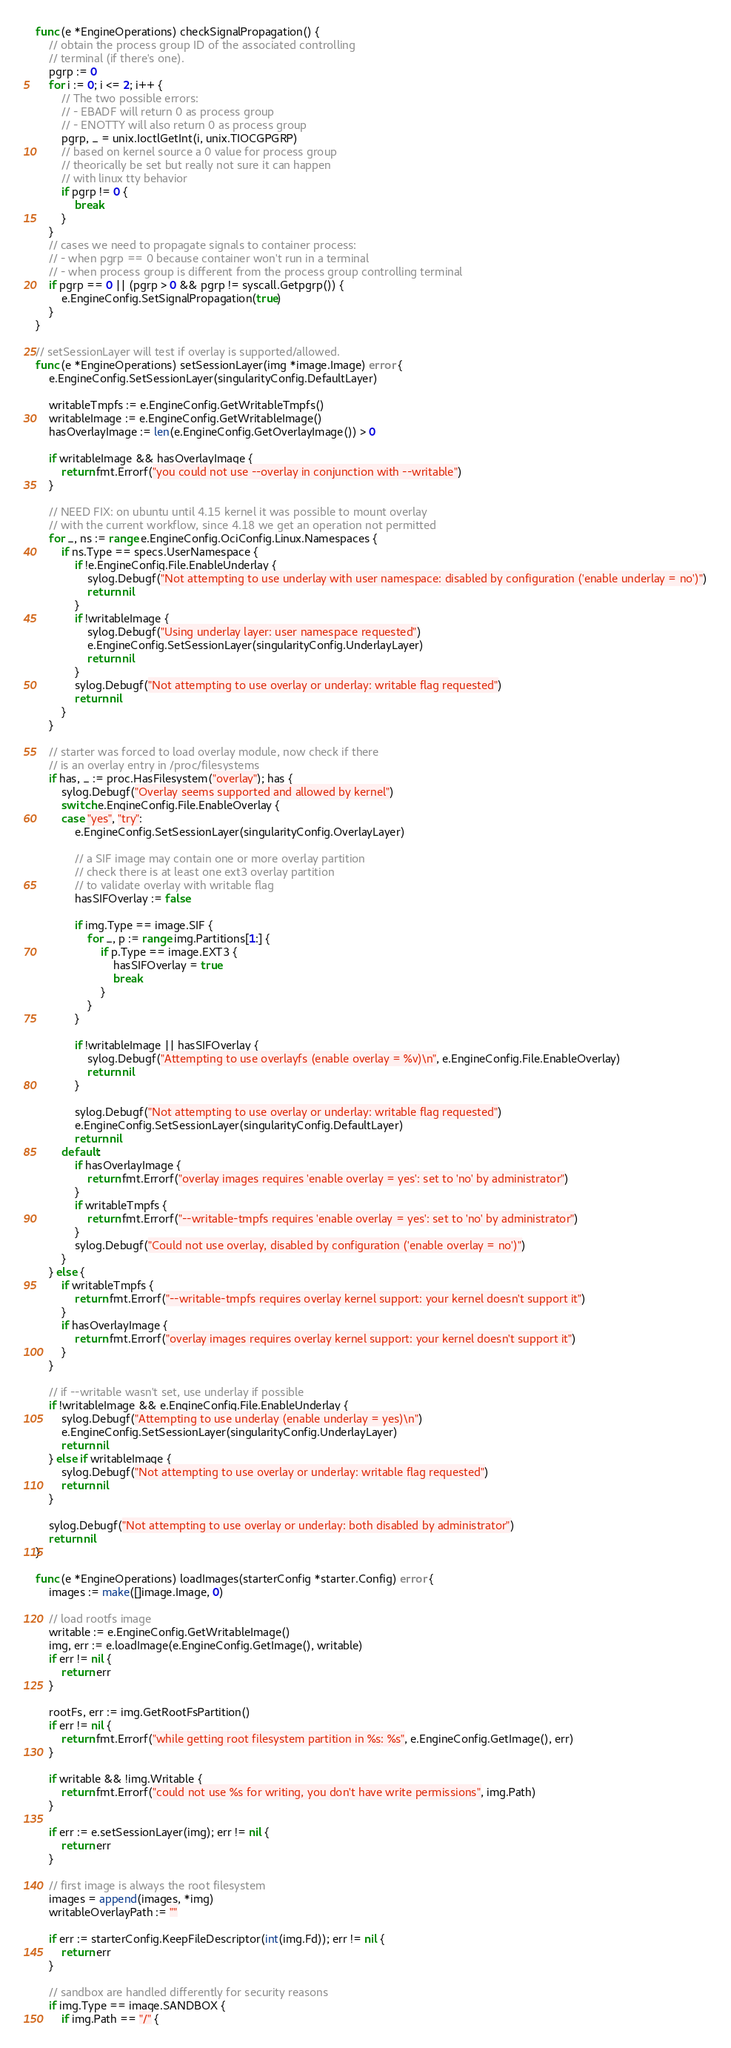Convert code to text. <code><loc_0><loc_0><loc_500><loc_500><_Go_>func (e *EngineOperations) checkSignalPropagation() {
	// obtain the process group ID of the associated controlling
	// terminal (if there's one).
	pgrp := 0
	for i := 0; i <= 2; i++ {
		// The two possible errors:
		// - EBADF will return 0 as process group
		// - ENOTTY will also return 0 as process group
		pgrp, _ = unix.IoctlGetInt(i, unix.TIOCGPGRP)
		// based on kernel source a 0 value for process group
		// theorically be set but really not sure it can happen
		// with linux tty behavior
		if pgrp != 0 {
			break
		}
	}
	// cases we need to propagate signals to container process:
	// - when pgrp == 0 because container won't run in a terminal
	// - when process group is different from the process group controlling terminal
	if pgrp == 0 || (pgrp > 0 && pgrp != syscall.Getpgrp()) {
		e.EngineConfig.SetSignalPropagation(true)
	}
}

// setSessionLayer will test if overlay is supported/allowed.
func (e *EngineOperations) setSessionLayer(img *image.Image) error {
	e.EngineConfig.SetSessionLayer(singularityConfig.DefaultLayer)

	writableTmpfs := e.EngineConfig.GetWritableTmpfs()
	writableImage := e.EngineConfig.GetWritableImage()
	hasOverlayImage := len(e.EngineConfig.GetOverlayImage()) > 0

	if writableImage && hasOverlayImage {
		return fmt.Errorf("you could not use --overlay in conjunction with --writable")
	}

	// NEED FIX: on ubuntu until 4.15 kernel it was possible to mount overlay
	// with the current workflow, since 4.18 we get an operation not permitted
	for _, ns := range e.EngineConfig.OciConfig.Linux.Namespaces {
		if ns.Type == specs.UserNamespace {
			if !e.EngineConfig.File.EnableUnderlay {
				sylog.Debugf("Not attempting to use underlay with user namespace: disabled by configuration ('enable underlay = no')")
				return nil
			}
			if !writableImage {
				sylog.Debugf("Using underlay layer: user namespace requested")
				e.EngineConfig.SetSessionLayer(singularityConfig.UnderlayLayer)
				return nil
			}
			sylog.Debugf("Not attempting to use overlay or underlay: writable flag requested")
			return nil
		}
	}

	// starter was forced to load overlay module, now check if there
	// is an overlay entry in /proc/filesystems
	if has, _ := proc.HasFilesystem("overlay"); has {
		sylog.Debugf("Overlay seems supported and allowed by kernel")
		switch e.EngineConfig.File.EnableOverlay {
		case "yes", "try":
			e.EngineConfig.SetSessionLayer(singularityConfig.OverlayLayer)

			// a SIF image may contain one or more overlay partition
			// check there is at least one ext3 overlay partition
			// to validate overlay with writable flag
			hasSIFOverlay := false

			if img.Type == image.SIF {
				for _, p := range img.Partitions[1:] {
					if p.Type == image.EXT3 {
						hasSIFOverlay = true
						break
					}
				}
			}

			if !writableImage || hasSIFOverlay {
				sylog.Debugf("Attempting to use overlayfs (enable overlay = %v)\n", e.EngineConfig.File.EnableOverlay)
				return nil
			}

			sylog.Debugf("Not attempting to use overlay or underlay: writable flag requested")
			e.EngineConfig.SetSessionLayer(singularityConfig.DefaultLayer)
			return nil
		default:
			if hasOverlayImage {
				return fmt.Errorf("overlay images requires 'enable overlay = yes': set to 'no' by administrator")
			}
			if writableTmpfs {
				return fmt.Errorf("--writable-tmpfs requires 'enable overlay = yes': set to 'no' by administrator")
			}
			sylog.Debugf("Could not use overlay, disabled by configuration ('enable overlay = no')")
		}
	} else {
		if writableTmpfs {
			return fmt.Errorf("--writable-tmpfs requires overlay kernel support: your kernel doesn't support it")
		}
		if hasOverlayImage {
			return fmt.Errorf("overlay images requires overlay kernel support: your kernel doesn't support it")
		}
	}

	// if --writable wasn't set, use underlay if possible
	if !writableImage && e.EngineConfig.File.EnableUnderlay {
		sylog.Debugf("Attempting to use underlay (enable underlay = yes)\n")
		e.EngineConfig.SetSessionLayer(singularityConfig.UnderlayLayer)
		return nil
	} else if writableImage {
		sylog.Debugf("Not attempting to use overlay or underlay: writable flag requested")
		return nil
	}

	sylog.Debugf("Not attempting to use overlay or underlay: both disabled by administrator")
	return nil
}

func (e *EngineOperations) loadImages(starterConfig *starter.Config) error {
	images := make([]image.Image, 0)

	// load rootfs image
	writable := e.EngineConfig.GetWritableImage()
	img, err := e.loadImage(e.EngineConfig.GetImage(), writable)
	if err != nil {
		return err
	}

	rootFs, err := img.GetRootFsPartition()
	if err != nil {
		return fmt.Errorf("while getting root filesystem partition in %s: %s", e.EngineConfig.GetImage(), err)
	}

	if writable && !img.Writable {
		return fmt.Errorf("could not use %s for writing, you don't have write permissions", img.Path)
	}

	if err := e.setSessionLayer(img); err != nil {
		return err
	}

	// first image is always the root filesystem
	images = append(images, *img)
	writableOverlayPath := ""

	if err := starterConfig.KeepFileDescriptor(int(img.Fd)); err != nil {
		return err
	}

	// sandbox are handled differently for security reasons
	if img.Type == image.SANDBOX {
		if img.Path == "/" {</code> 